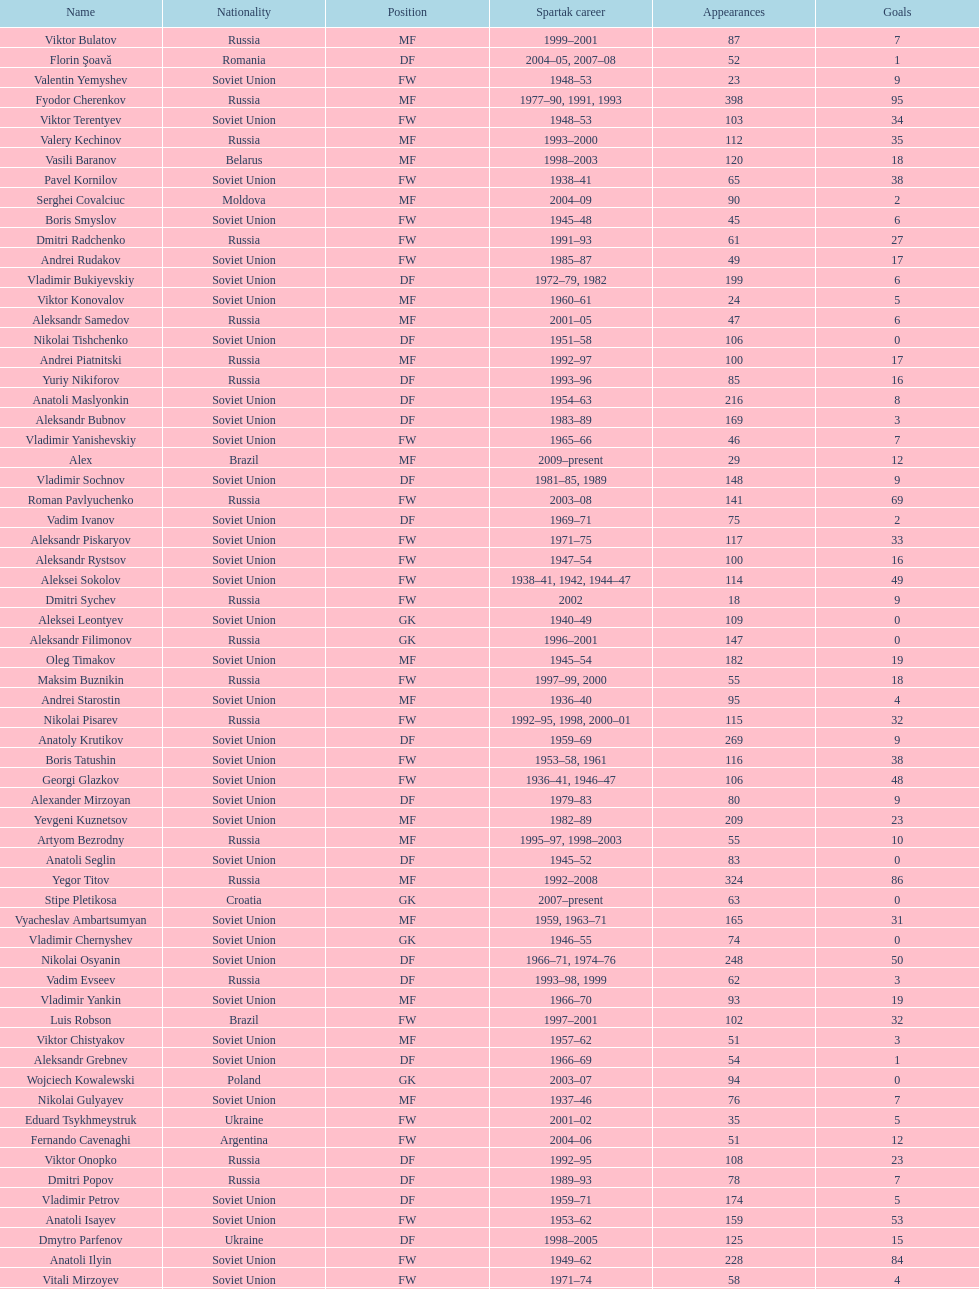Which player has the highest number of goals? Nikita Simonyan. 